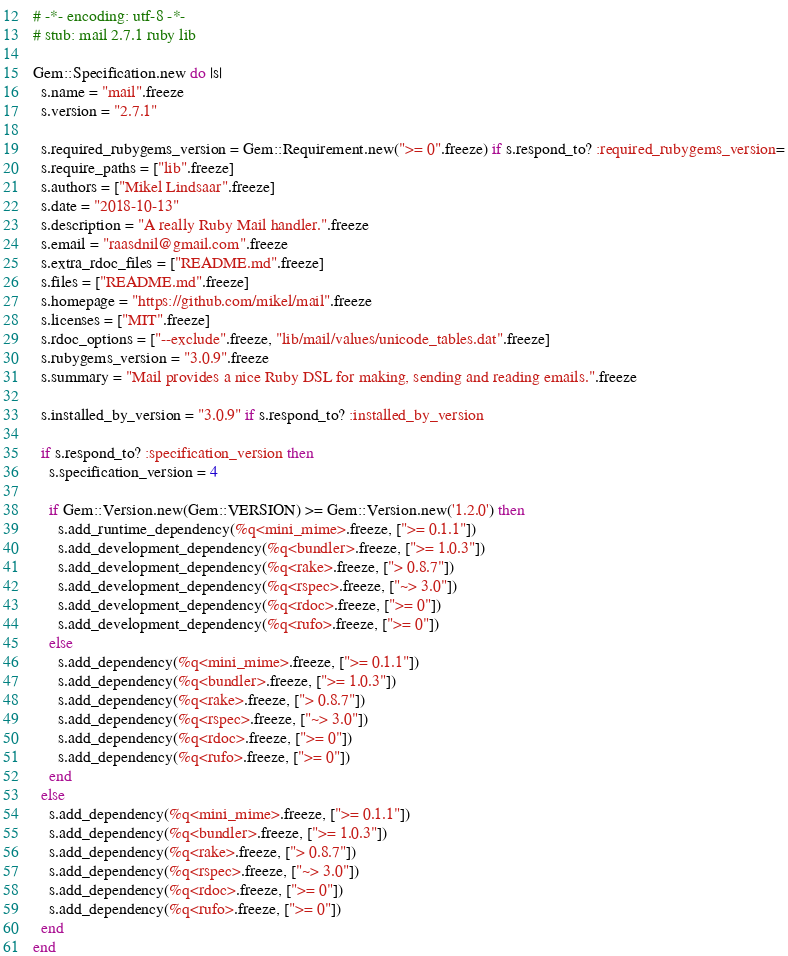Convert code to text. <code><loc_0><loc_0><loc_500><loc_500><_Ruby_># -*- encoding: utf-8 -*-
# stub: mail 2.7.1 ruby lib

Gem::Specification.new do |s|
  s.name = "mail".freeze
  s.version = "2.7.1"

  s.required_rubygems_version = Gem::Requirement.new(">= 0".freeze) if s.respond_to? :required_rubygems_version=
  s.require_paths = ["lib".freeze]
  s.authors = ["Mikel Lindsaar".freeze]
  s.date = "2018-10-13"
  s.description = "A really Ruby Mail handler.".freeze
  s.email = "raasdnil@gmail.com".freeze
  s.extra_rdoc_files = ["README.md".freeze]
  s.files = ["README.md".freeze]
  s.homepage = "https://github.com/mikel/mail".freeze
  s.licenses = ["MIT".freeze]
  s.rdoc_options = ["--exclude".freeze, "lib/mail/values/unicode_tables.dat".freeze]
  s.rubygems_version = "3.0.9".freeze
  s.summary = "Mail provides a nice Ruby DSL for making, sending and reading emails.".freeze

  s.installed_by_version = "3.0.9" if s.respond_to? :installed_by_version

  if s.respond_to? :specification_version then
    s.specification_version = 4

    if Gem::Version.new(Gem::VERSION) >= Gem::Version.new('1.2.0') then
      s.add_runtime_dependency(%q<mini_mime>.freeze, [">= 0.1.1"])
      s.add_development_dependency(%q<bundler>.freeze, [">= 1.0.3"])
      s.add_development_dependency(%q<rake>.freeze, ["> 0.8.7"])
      s.add_development_dependency(%q<rspec>.freeze, ["~> 3.0"])
      s.add_development_dependency(%q<rdoc>.freeze, [">= 0"])
      s.add_development_dependency(%q<rufo>.freeze, [">= 0"])
    else
      s.add_dependency(%q<mini_mime>.freeze, [">= 0.1.1"])
      s.add_dependency(%q<bundler>.freeze, [">= 1.0.3"])
      s.add_dependency(%q<rake>.freeze, ["> 0.8.7"])
      s.add_dependency(%q<rspec>.freeze, ["~> 3.0"])
      s.add_dependency(%q<rdoc>.freeze, [">= 0"])
      s.add_dependency(%q<rufo>.freeze, [">= 0"])
    end
  else
    s.add_dependency(%q<mini_mime>.freeze, [">= 0.1.1"])
    s.add_dependency(%q<bundler>.freeze, [">= 1.0.3"])
    s.add_dependency(%q<rake>.freeze, ["> 0.8.7"])
    s.add_dependency(%q<rspec>.freeze, ["~> 3.0"])
    s.add_dependency(%q<rdoc>.freeze, [">= 0"])
    s.add_dependency(%q<rufo>.freeze, [">= 0"])
  end
end
</code> 